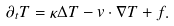Convert formula to latex. <formula><loc_0><loc_0><loc_500><loc_500>\partial _ { t } T = \kappa \Delta T - v \cdot \nabla T + f .</formula> 